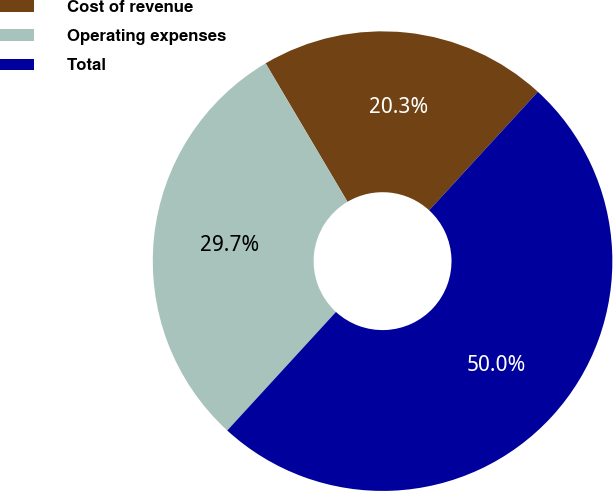<chart> <loc_0><loc_0><loc_500><loc_500><pie_chart><fcel>Cost of revenue<fcel>Operating expenses<fcel>Total<nl><fcel>20.31%<fcel>29.69%<fcel>50.0%<nl></chart> 